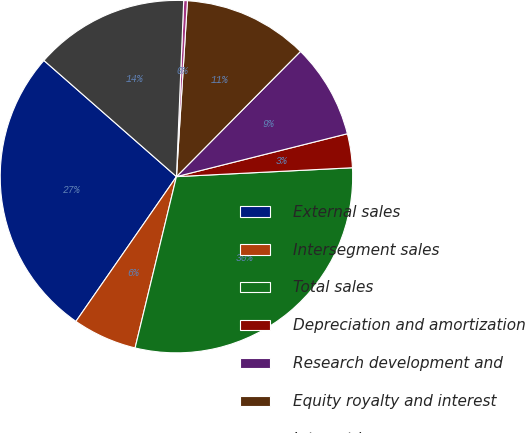<chart> <loc_0><loc_0><loc_500><loc_500><pie_chart><fcel>External sales<fcel>Intersegment sales<fcel>Total sales<fcel>Depreciation and amortization<fcel>Research development and<fcel>Equity royalty and interest<fcel>Interest income<fcel>Segment EBIT<nl><fcel>26.79%<fcel>5.89%<fcel>29.57%<fcel>3.11%<fcel>8.66%<fcel>11.43%<fcel>0.34%<fcel>14.2%<nl></chart> 